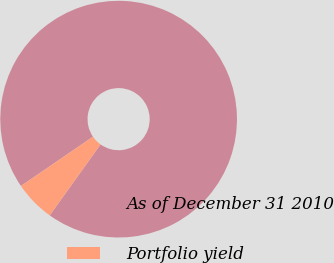<chart> <loc_0><loc_0><loc_500><loc_500><pie_chart><fcel>As of December 31 2010<fcel>Portfolio yield<nl><fcel>94.44%<fcel>5.56%<nl></chart> 